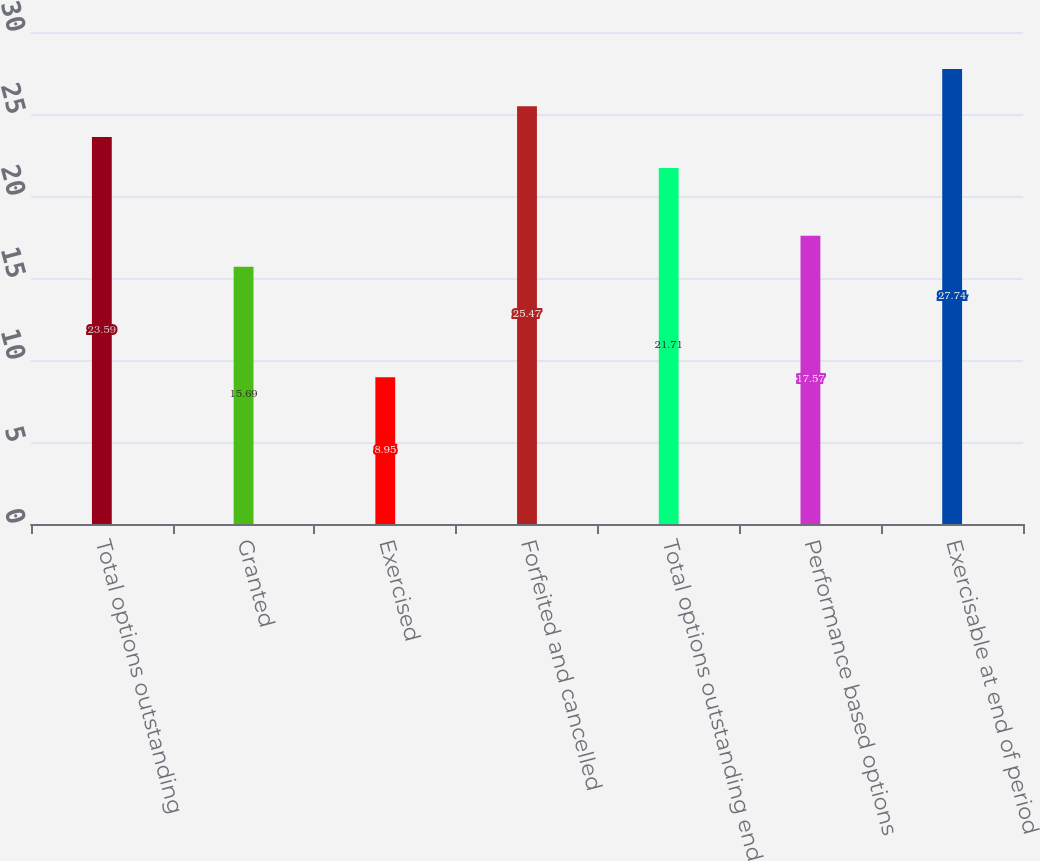Convert chart. <chart><loc_0><loc_0><loc_500><loc_500><bar_chart><fcel>Total options outstanding<fcel>Granted<fcel>Exercised<fcel>Forfeited and cancelled<fcel>Total options outstanding end<fcel>Performance based options<fcel>Exercisable at end of period<nl><fcel>23.59<fcel>15.69<fcel>8.95<fcel>25.47<fcel>21.71<fcel>17.57<fcel>27.74<nl></chart> 